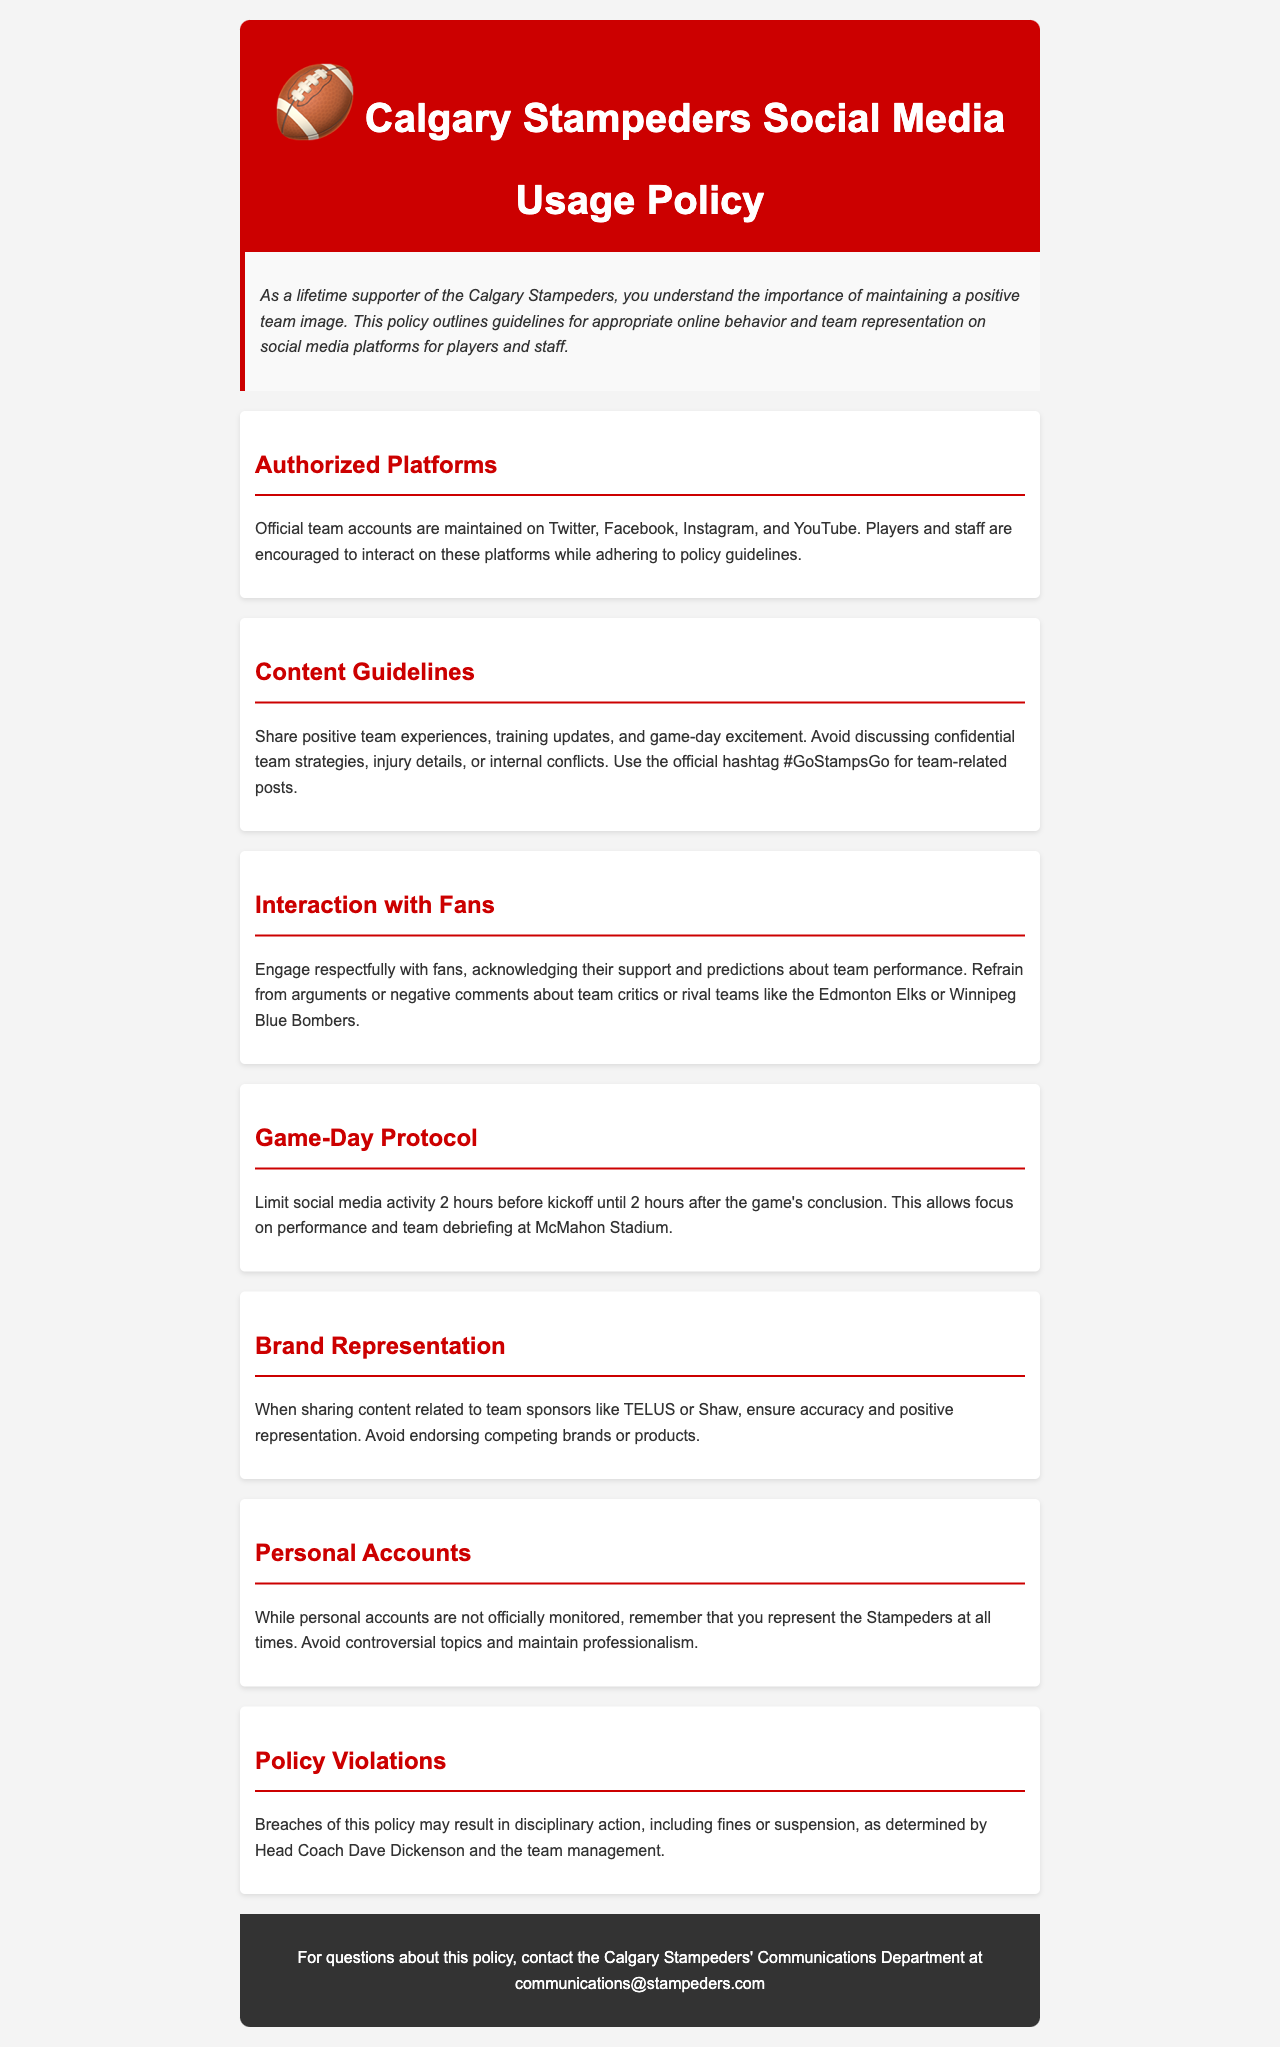What are the authorized platforms for team social media? The authorized platforms are listed in the document as Twitter, Facebook, Instagram, and YouTube.
Answer: Twitter, Facebook, Instagram, YouTube What is the official hashtag for team-related posts? The document specifies that the official hashtag to use is #GoStampsGo.
Answer: #GoStampsGo How long before and after a game should players limit social media activity? The policy outlines a time frame of 2 hours before and after the game for limiting social media activity.
Answer: 2 hours Who determines disciplinary actions for policy violations? The document states that disciplinary actions are determined by Head Coach Dave Dickenson and the team management.
Answer: Head Coach Dave Dickenson What should players avoid discussing online? The content guidelines indicate that players should avoid discussing confidential team strategies, injury details, or internal conflicts.
Answer: Confidential team strategies, injury details, internal conflicts What type of topics should be avoided on personal accounts? The document mentions that players should avoid controversial topics on their personal accounts.
Answer: Controversial topics How should players interact with fans on social media? The interaction guidelines indicate that players should engage respectfully with fans.
Answer: Engage respectfully What is the consequence of breaching the social media policy? The document states that breaches of the policy may result in disciplinary action, including fines or suspension.
Answer: Disciplinary action, fines, suspension 